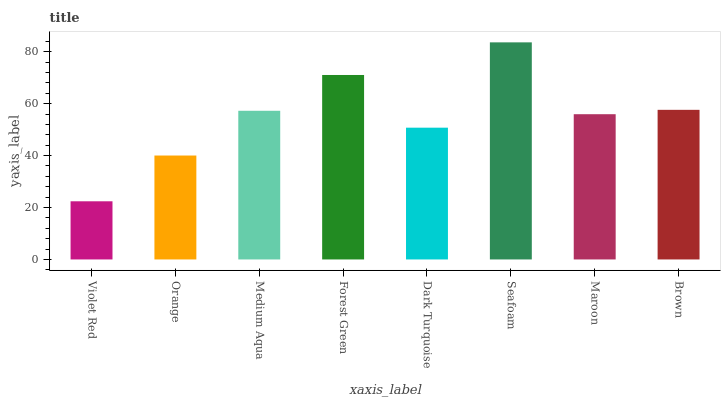Is Violet Red the minimum?
Answer yes or no. Yes. Is Seafoam the maximum?
Answer yes or no. Yes. Is Orange the minimum?
Answer yes or no. No. Is Orange the maximum?
Answer yes or no. No. Is Orange greater than Violet Red?
Answer yes or no. Yes. Is Violet Red less than Orange?
Answer yes or no. Yes. Is Violet Red greater than Orange?
Answer yes or no. No. Is Orange less than Violet Red?
Answer yes or no. No. Is Medium Aqua the high median?
Answer yes or no. Yes. Is Maroon the low median?
Answer yes or no. Yes. Is Dark Turquoise the high median?
Answer yes or no. No. Is Dark Turquoise the low median?
Answer yes or no. No. 